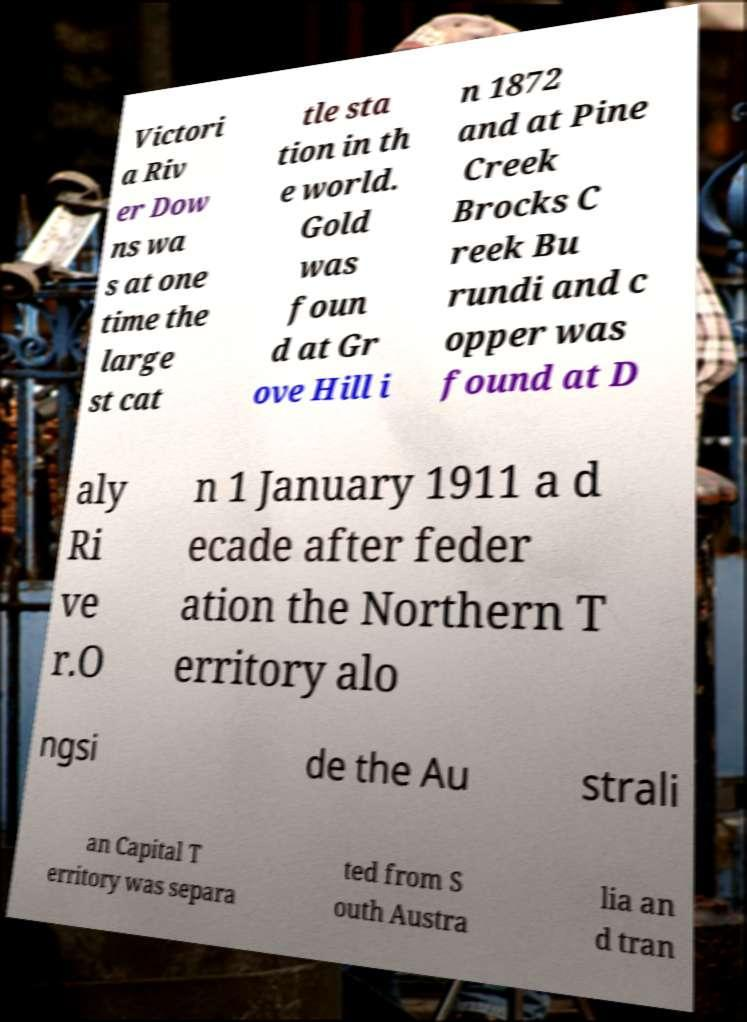Can you read and provide the text displayed in the image?This photo seems to have some interesting text. Can you extract and type it out for me? Victori a Riv er Dow ns wa s at one time the large st cat tle sta tion in th e world. Gold was foun d at Gr ove Hill i n 1872 and at Pine Creek Brocks C reek Bu rundi and c opper was found at D aly Ri ve r.O n 1 January 1911 a d ecade after feder ation the Northern T erritory alo ngsi de the Au strali an Capital T erritory was separa ted from S outh Austra lia an d tran 